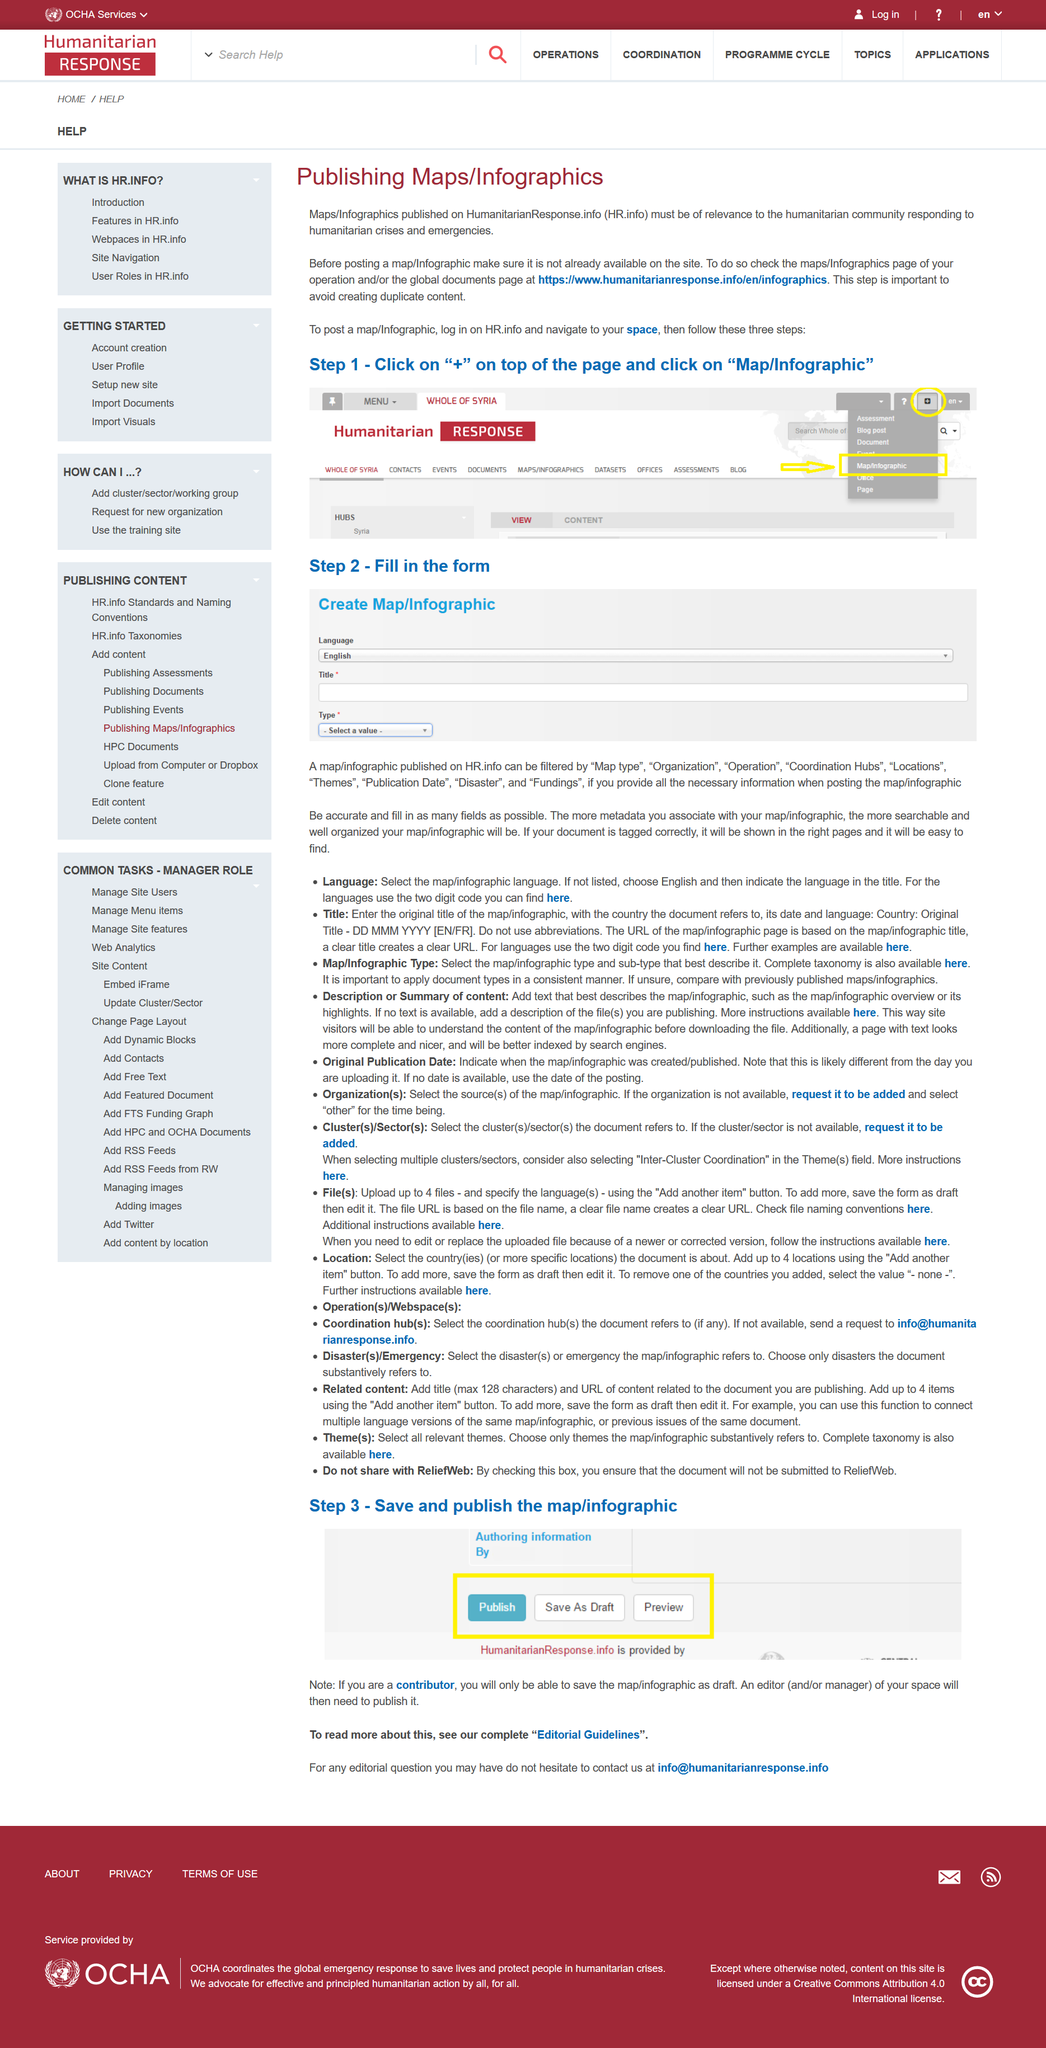List a handful of essential elements in this visual. A page with text will be better indexed by search engines than one without. HR.info allows users to filter maps and infographics by the category "Disaster. Humanitarian Response is what HR stands for, it is a term that refers to actions taken to help and support people in need, particularly in times of crisis or emergency. This page is dedicated to the publication of maps and infographics. It is necessary for you to log in. 